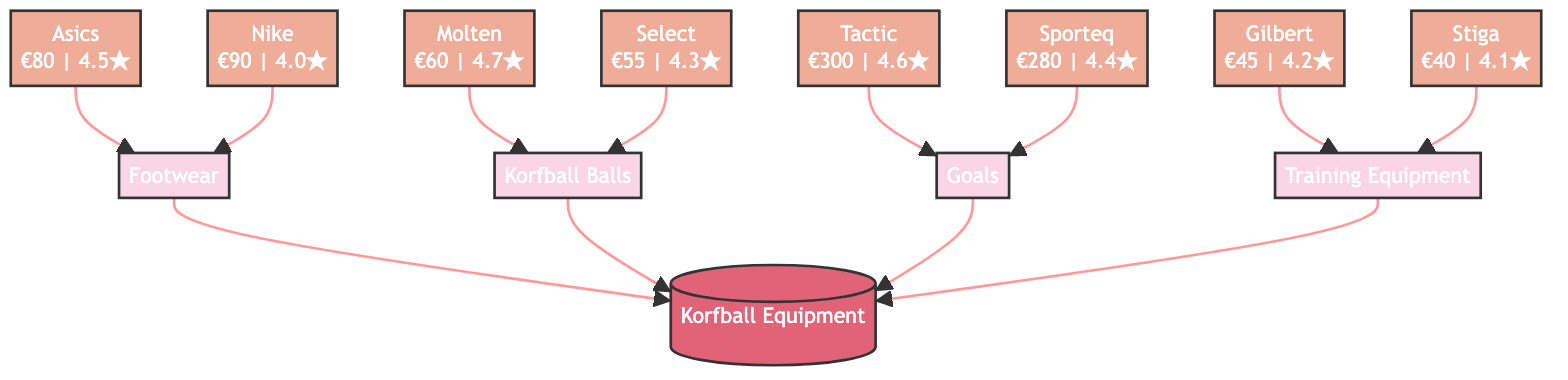How many brands are listed under footwear? The diagram shows two brands listed under the "Footwear" category: "Asics" and "Nike". To determine the number of brands, we simply count these entries.
Answer: 2 What is the average cost of a Molten ball? From the diagram, the "Molten" brand under "Korfball Balls" has an average cost of 60 euros. This information is directly stated in the brand's node.
Answer: 60 Which brand has the highest preference rating for training equipment? The diagram shows two brands under "Training Equipment": "Gilbert" with a preference rating of 4.2 and "Stiga" with 4.1. Comparing these ratings, "Gilbert" has the higher rating.
Answer: Gilbert What is the average cost of the cheapest footwear? The "Footwear" node lists "Asics" with an average cost of 80 euros and "Nike" with 90 euros. The cheaper option is "Asics" at 80 euros, which we identify by comparing the costs.
Answer: 80 Which equipment category has the most expensive brand? Looking at the "Goals" category, "Tactic" is listed with an average cost of 300 euros, which is higher than any other listed costs in footwear, balls, or training. This indicates that the "Goals" category contains the most expensive brand.
Answer: Goals What is the average cost of all Korfball equipment brands combined? To find the average cost, we sum the costs of all brands: 80 (Asics) + 90 (Nike) + 60 (Molten) + 55 (Select) + 300 (Tactic) + 280 (Sporteq) + 45 (Gilbert) + 40 (Stiga) = 950 euros. There are 8 brands, so the average is 950 / 8 = 118.75 euros.
Answer: 118.75 Which brand has the lowest average cost? Reviewing the costs listed, we see "Stiga" with an average cost of 40 euros, making it the lowest among all brands in the diagram.
Answer: Stiga What preference rating does the most expensive korfball ball have? The "Goals" category shows "Tactic" with an average cost of 300 euros, but we need the rating of the most expensive korfball ball. Under "Korfball Balls," "Molten" has the higher preference rating of 4.7 compared to "Select." Hence, we answer based on the korfball balls, not the goals.
Answer: 4.7 How many types of korfball equipment are listed? The diagram lists four types of korfball equipment: "Footwear", "Korfball Balls", "Goals", and "Training Equipment". Counting these gives us the total number.
Answer: 4 